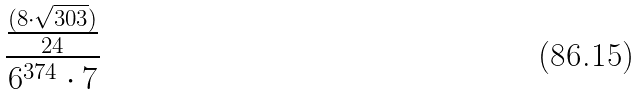<formula> <loc_0><loc_0><loc_500><loc_500>\frac { \frac { ( 8 \cdot \sqrt { 3 0 3 } ) } { 2 4 } } { 6 ^ { 3 7 4 } \cdot 7 }</formula> 